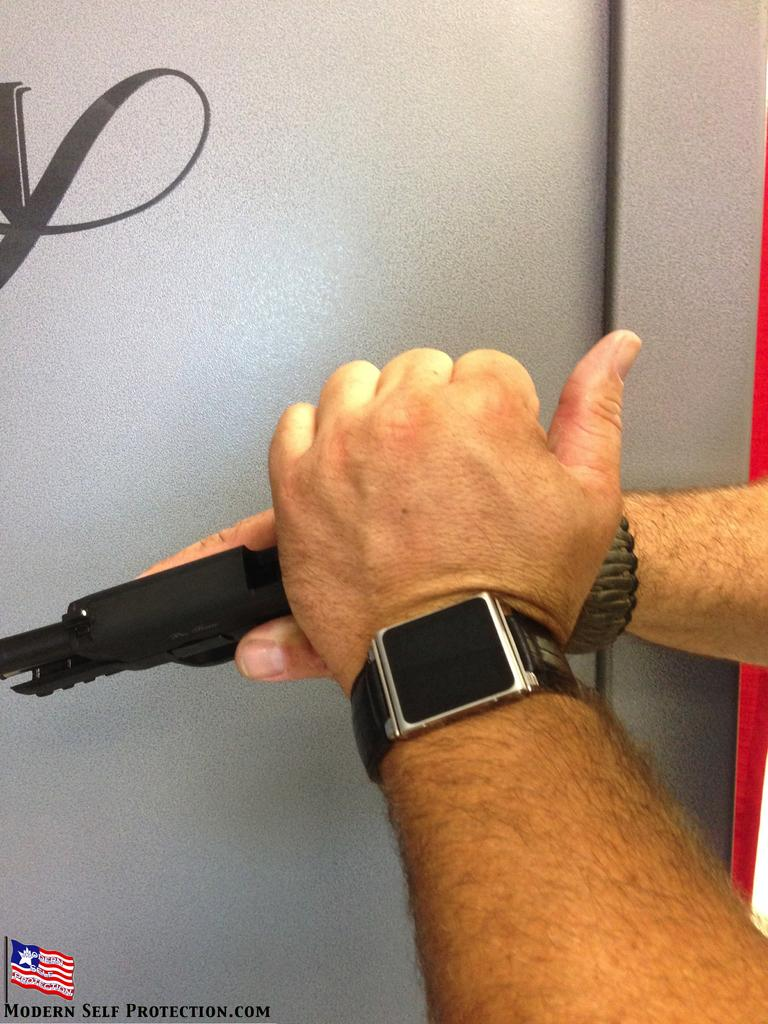<image>
Share a concise interpretation of the image provided. A modern self protection ad shows a person holding a gun. 